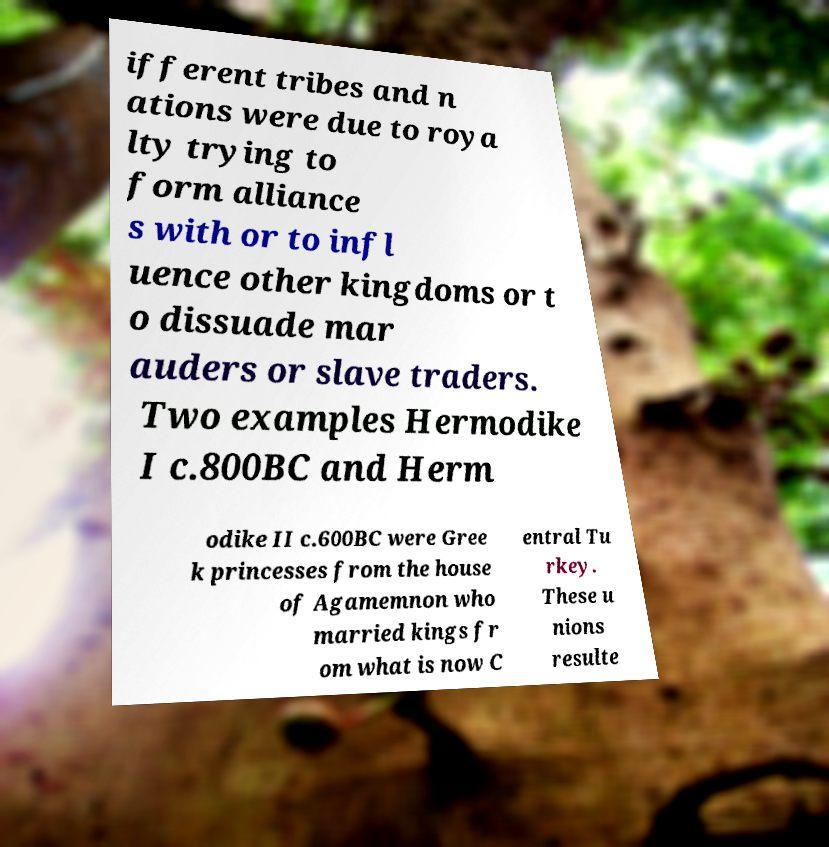I need the written content from this picture converted into text. Can you do that? ifferent tribes and n ations were due to roya lty trying to form alliance s with or to infl uence other kingdoms or t o dissuade mar auders or slave traders. Two examples Hermodike I c.800BC and Herm odike II c.600BC were Gree k princesses from the house of Agamemnon who married kings fr om what is now C entral Tu rkey. These u nions resulte 